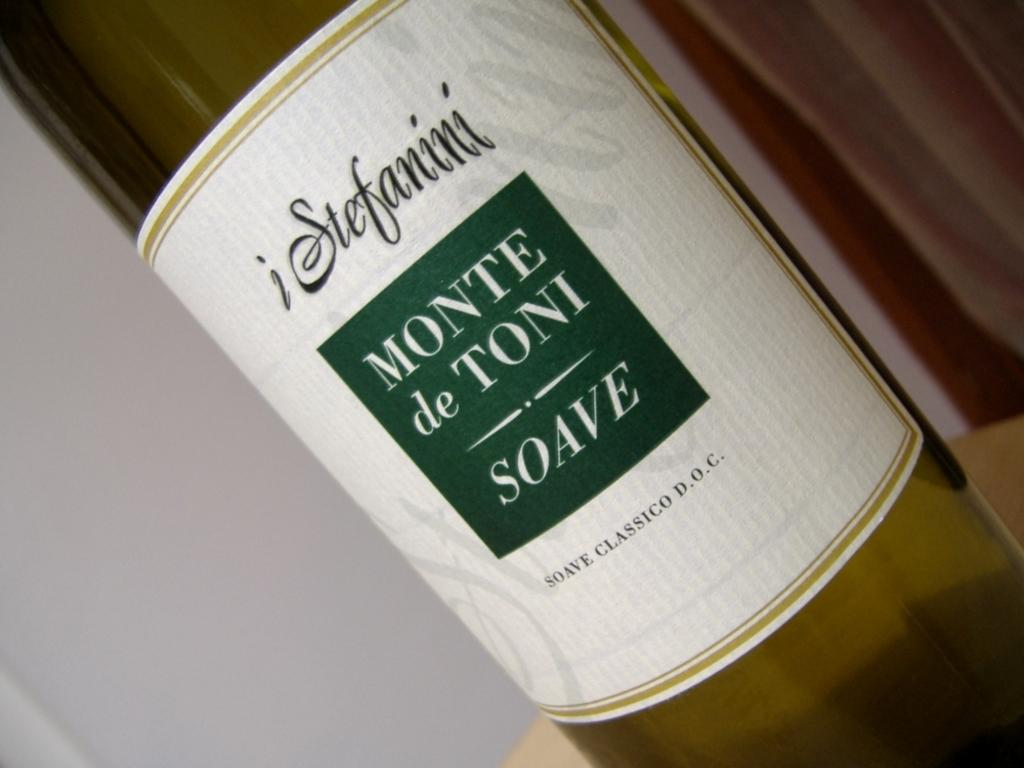<image>
Describe the image concisely. a wine bottle that is called 'monte de toni soave' 